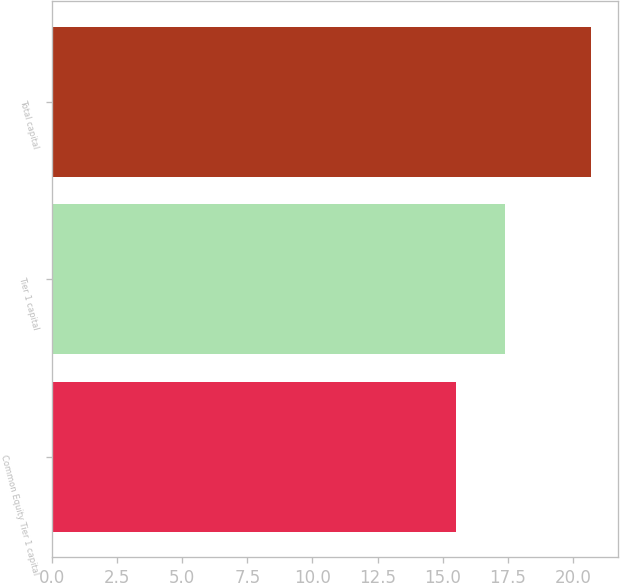<chart> <loc_0><loc_0><loc_500><loc_500><bar_chart><fcel>Common Equity Tier 1 capital<fcel>Tier 1 capital<fcel>Total capital<nl><fcel>15.5<fcel>17.4<fcel>20.7<nl></chart> 